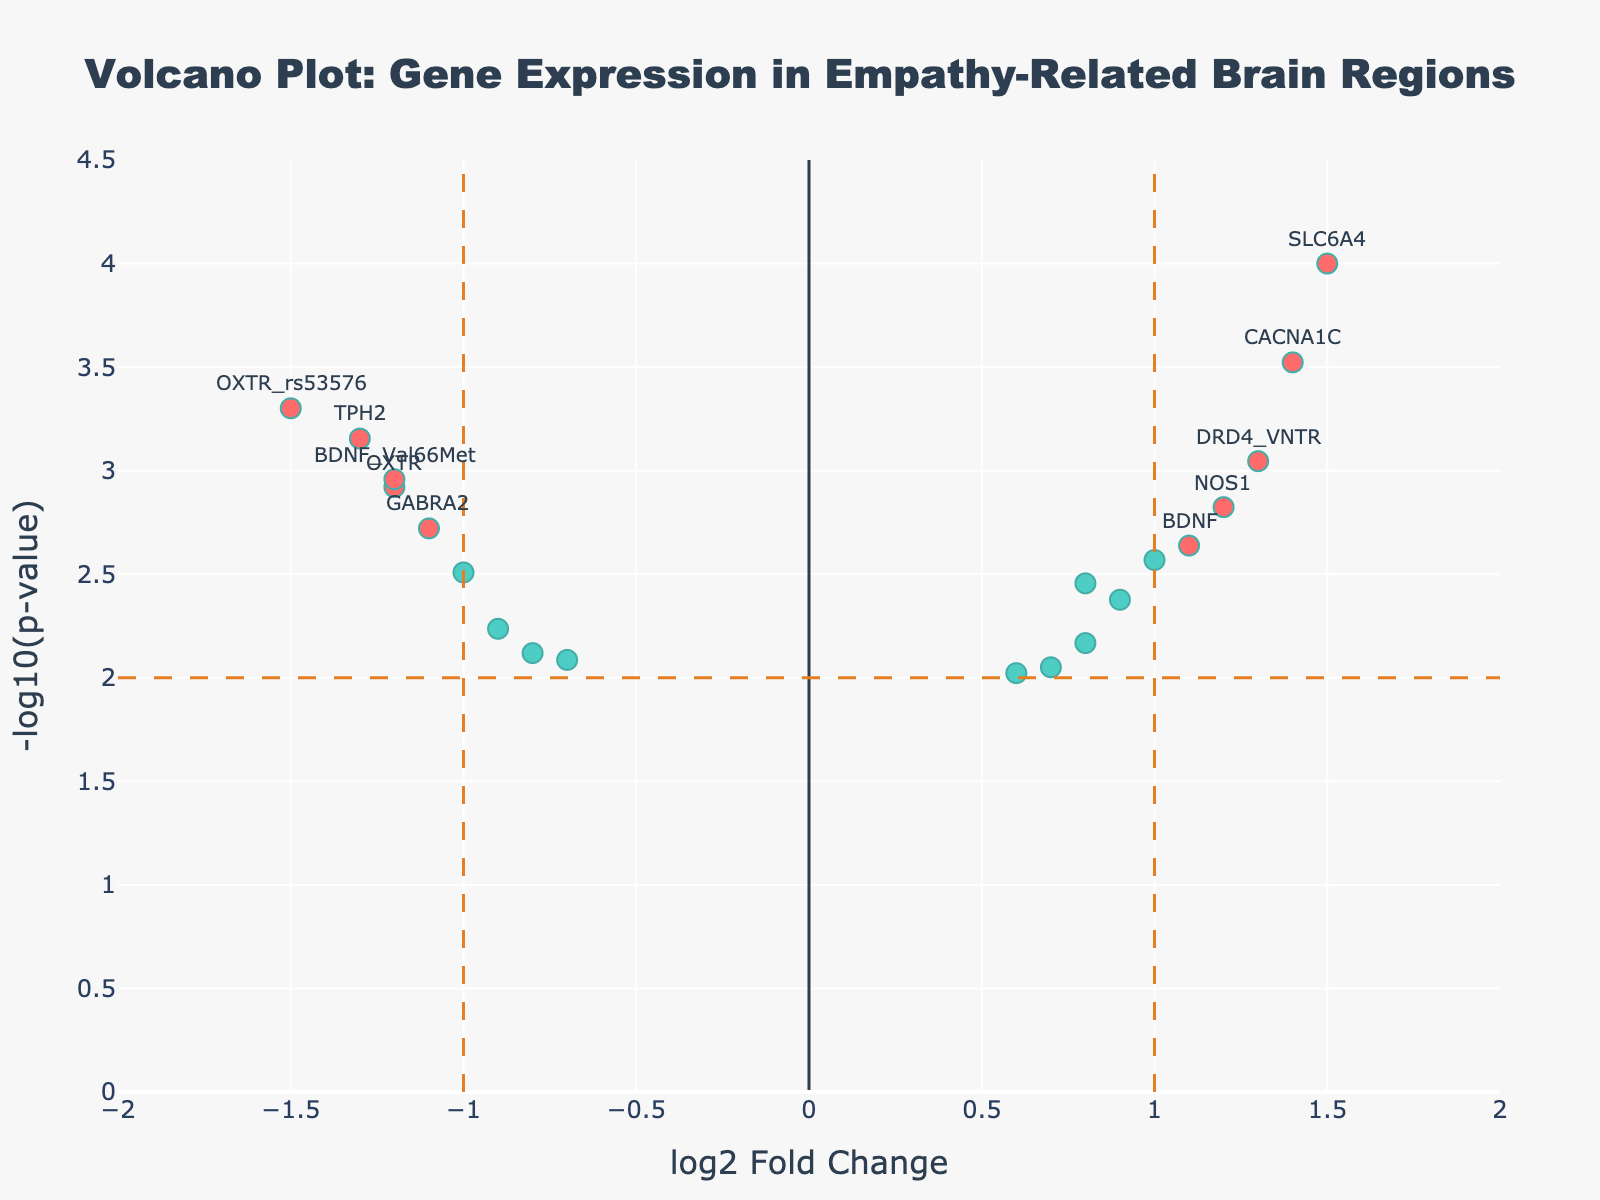How many data points are marked as significant in the plot? To find the number of significant data points, look for markers colored differently from the rest. In this plot, significant points are colored differently. Count these points.
Answer: 10 What does the x-axis represent in this plot? The x-axis shows the log2 fold change for each gene, indicating the fold change in gene expression.
Answer: log2 fold change Which gene has the highest -log10(p-value) and what is it? Identify the point with the highest y-value, then check the gene label.
Answer: SLC6A4, 4.0 What is the range for the x-axis in the plot? Examine the x-axis labels to determine the minimum and maximum values.
Answer: -2 to 2 What color represents non-significant data points in the plot? Observe the color of the points that are not labeled as significant.
Answer: A different shade (e.g., cyan) Which gene has the highest positive log2 fold change? Find the point furthest to the right along the x-axis, then check the gene label.
Answer: SLC6A4 Are there more genes with positive log2 fold change or negative log2 fold change? Count the number of points on either side of the y-axis (positive on the right, negative on the left).
Answer: Positive How can you tell if a gene is significant in this plot? Significant genes are those with a p-value less than the threshold (0.01) and a log2 fold change greater than 1 or less than -1, marked in a highlighted color.
Answer: Highlighted color Between the genes OXTR and OXTR_rs53576, which one shows a more significant change and why? Compare both their log2 fold change and -log10(p-value). OXTR_rs53576 has lower p-value and more negative fold change.
Answer: OXTR_rs53576 What does a higher -log10(p-value) indicate about a gene's significance in this context? A higher -log10(p-value) means a lower p-value, indicating greater statistical significance.
Answer: Greater significance 